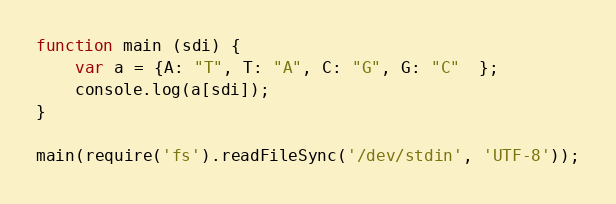Convert code to text. <code><loc_0><loc_0><loc_500><loc_500><_JavaScript_>function main (sdi) {
    var a = {A: "T", T: "A", C: "G", G: "C"  };
	console.log(a[sdi]);
}

main(require('fs').readFileSync('/dev/stdin', 'UTF-8'));</code> 